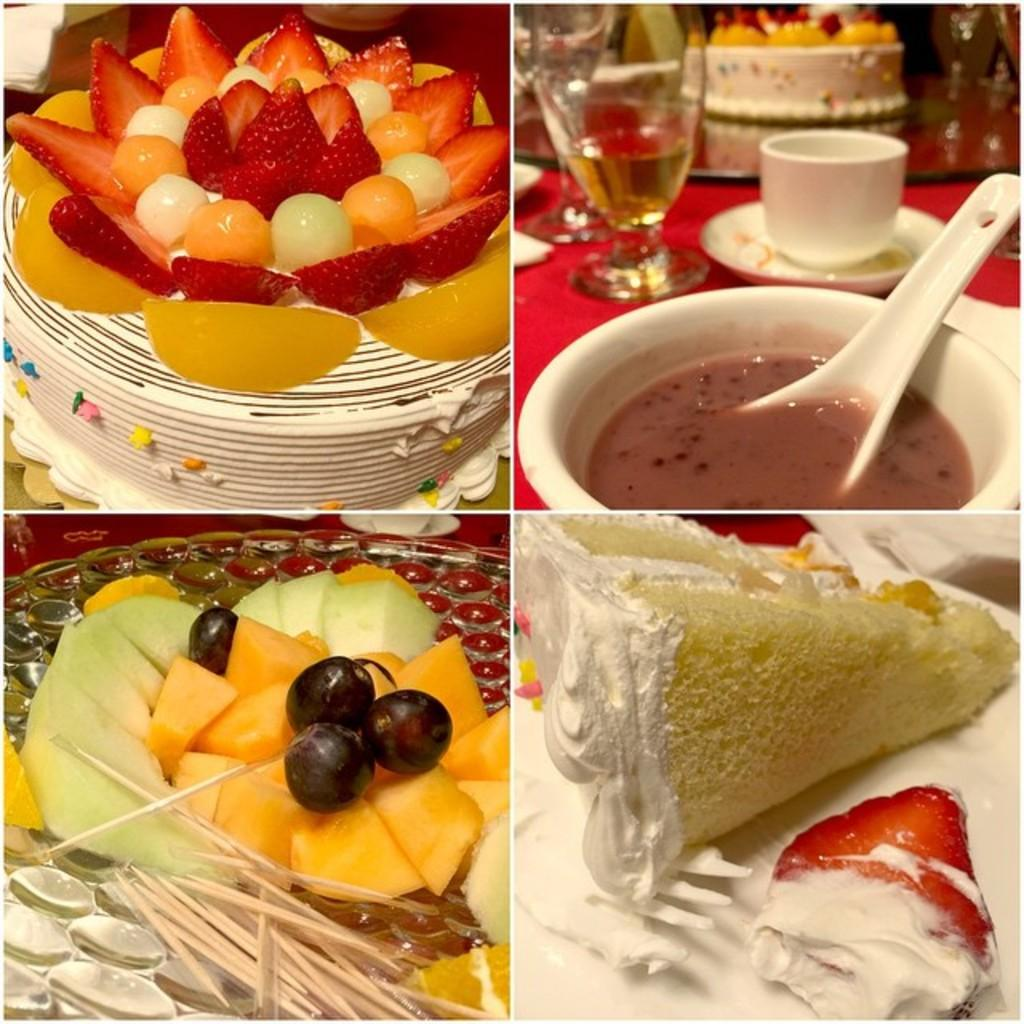What is the main food item featured in the image? There is a cake in the image. What other food items can be seen in the image? There are fruits on a plate and a bowl with food in the image. What utensil is used for the food in the bowl? There is a spoon in the bowl in the image. What type of drinkware is present in the image? There is: There is a glass and a cup and saucer in the image. What type of cable is connected to the cake in the image? There is no cable connected to the cake in the image; it is a dessert and not an electronic device. 